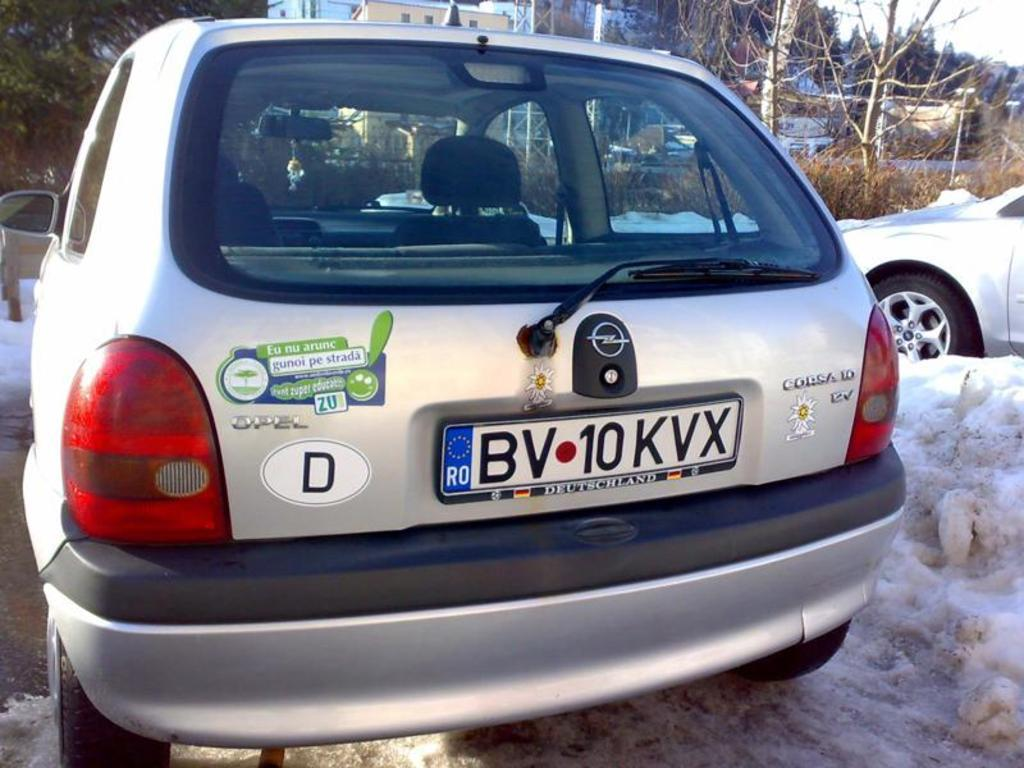<image>
Provide a brief description of the given image. A car with a license plate number BV 10KVX 